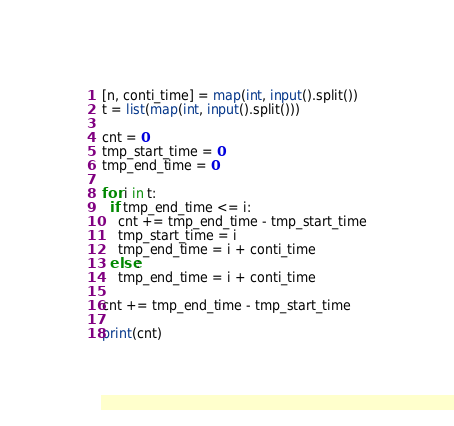<code> <loc_0><loc_0><loc_500><loc_500><_Python_>[n, conti_time] = map(int, input().split())
t = list(map(int, input().split()))

cnt = 0
tmp_start_time = 0
tmp_end_time = 0

for i in t:
  if tmp_end_time <= i:
    cnt += tmp_end_time - tmp_start_time
    tmp_start_time = i
    tmp_end_time = i + conti_time
  else:
    tmp_end_time = i + conti_time

cnt += tmp_end_time - tmp_start_time

print(cnt)</code> 